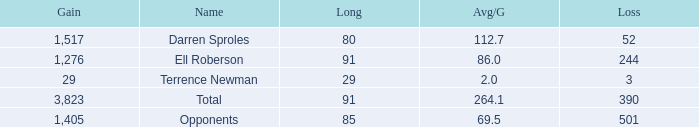What's the sum of all average yards gained when the gained yards is under 1,276 and lost more than 3 yards? None. 